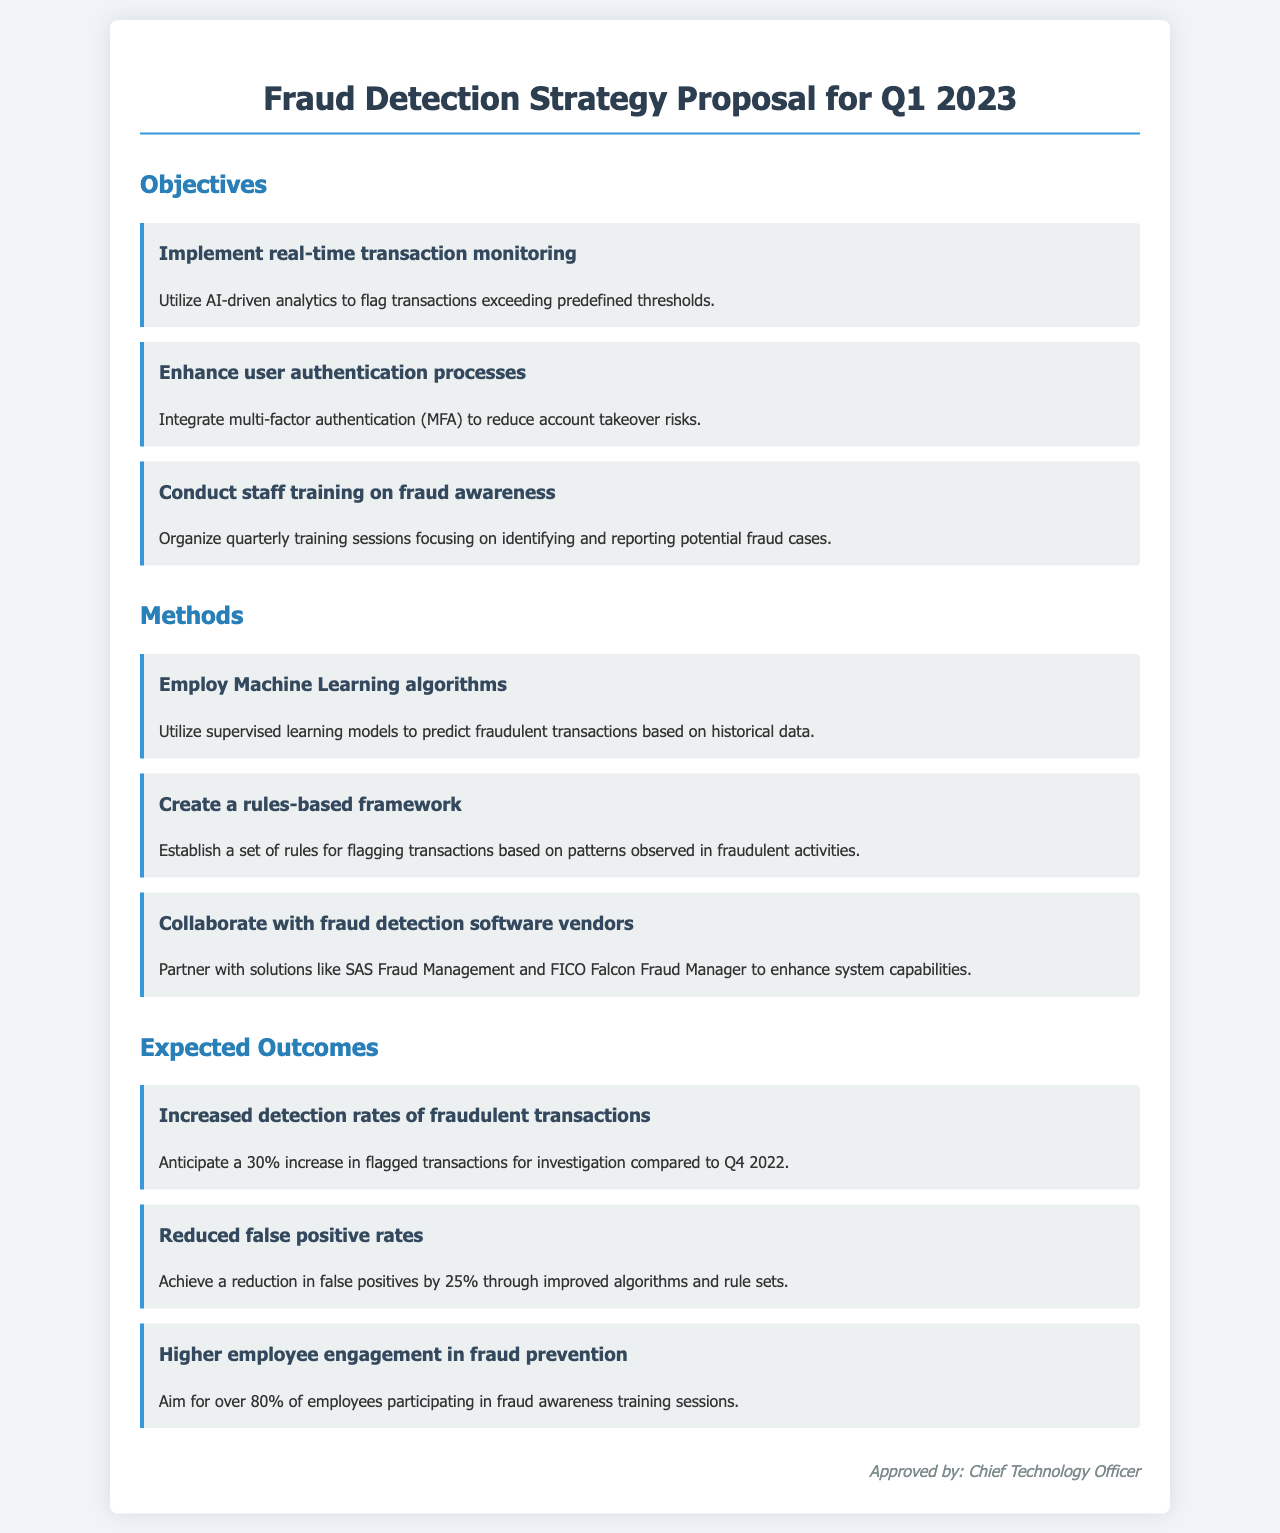what is the primary objective of the fraud detection strategy? The primary objective mentioned in the document includes implementing real-time transaction monitoring using AI-driven analytics.
Answer: Implement real-time transaction monitoring which method involves predictive modeling? The method that utilizes predictive modeling as per the document is employing machine learning algorithms to predict fraudulent transactions based on historical data.
Answer: Employ Machine Learning algorithms what is the expected increase in detection rates of fraudulent transactions? The expected outcome indicates an anticipated increase in flagged transactions for investigation of 30% compared to Q4 2022.
Answer: 30% which vendor is mentioned for collaboration in fraud detection? The document mentions collaborating with SAS Fraud Management and FICO Falcon Fraud Manager as software vendors for enhancing system capabilities.
Answer: SAS Fraud Management and FICO Falcon Fraud Manager what is the target percentage for employee participation in fraud awareness training? The expected outcome specifies aiming for over 80% of employees to participate in fraud awareness training sessions.
Answer: over 80% 